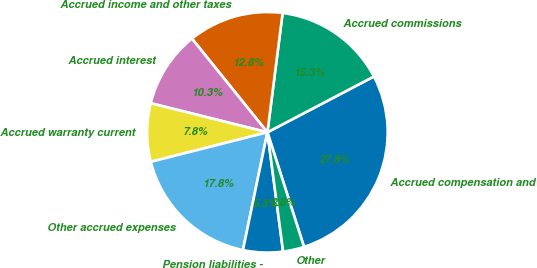Convert chart to OTSL. <chart><loc_0><loc_0><loc_500><loc_500><pie_chart><fcel>Accrued compensation and<fcel>Accrued commissions<fcel>Accrued income and other taxes<fcel>Accrued interest<fcel>Accrued warranty current<fcel>Other accrued expenses<fcel>Pension liabilities -<fcel>Other<nl><fcel>27.76%<fcel>15.3%<fcel>12.81%<fcel>10.32%<fcel>7.83%<fcel>17.8%<fcel>5.34%<fcel>2.84%<nl></chart> 